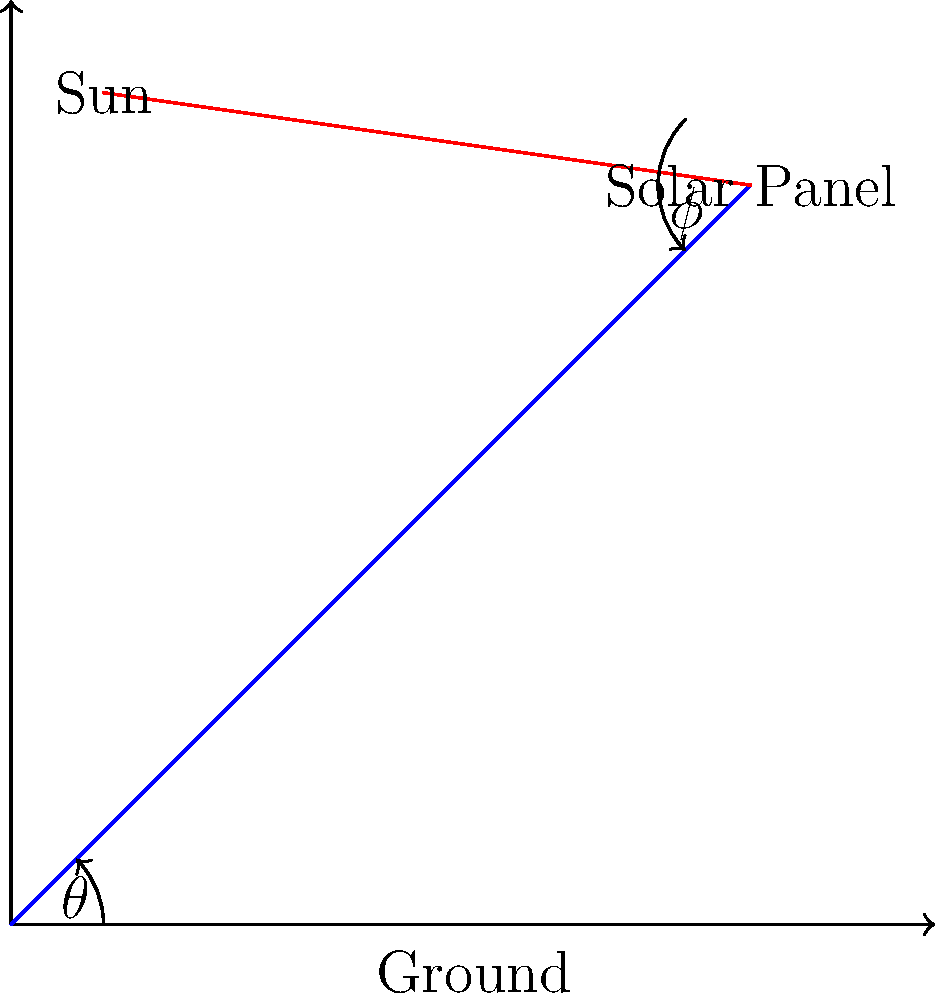As part of your latest environmental campaign in the Pacific, you're assessing the efficiency of a new solar panel array. The array is tilted at an angle $\theta = 30°$ from the horizontal, and the sun's rays are hitting the panel at an angle $\phi = 60°$ from the panel's surface normal. If the incoming solar radiation has an intensity of 1000 W/m², what is the power output per square meter of the solar panel, assuming it has an efficiency of 20%? To solve this problem, we need to follow these steps:

1) First, we need to calculate the effective area of the solar panel exposed to the sun's rays. This is given by $A_{eff} = A \cos(\phi)$, where $A$ is the actual area of the panel.

2) The power received by the panel is the product of the effective area and the incoming solar radiation intensity:
   $P_{received} = I \cdot A_{eff} = I \cdot A \cos(\phi)$

3) Where $I$ is the solar radiation intensity (1000 W/m²) and $\phi = 60°$.

4) Substituting the values:
   $P_{received} = 1000 \text{ W/m²} \cdot \cos(60°) = 1000 \cdot 0.5 = 500 \text{ W/m²}$

5) Now, considering the efficiency of the solar panel (20% or 0.2):
   $P_{output} = P_{received} \cdot \text{efficiency} = 500 \text{ W/m²} \cdot 0.2 = 100 \text{ W/m²}$

Note: The angle $\theta$ doesn't directly affect the calculation in this case, as we're given the angle $\phi$ between the sun's rays and the panel's normal. However, $\theta$ would be important if we were calculating $\phi$ based on the sun's position in the sky.
Answer: 100 W/m² 